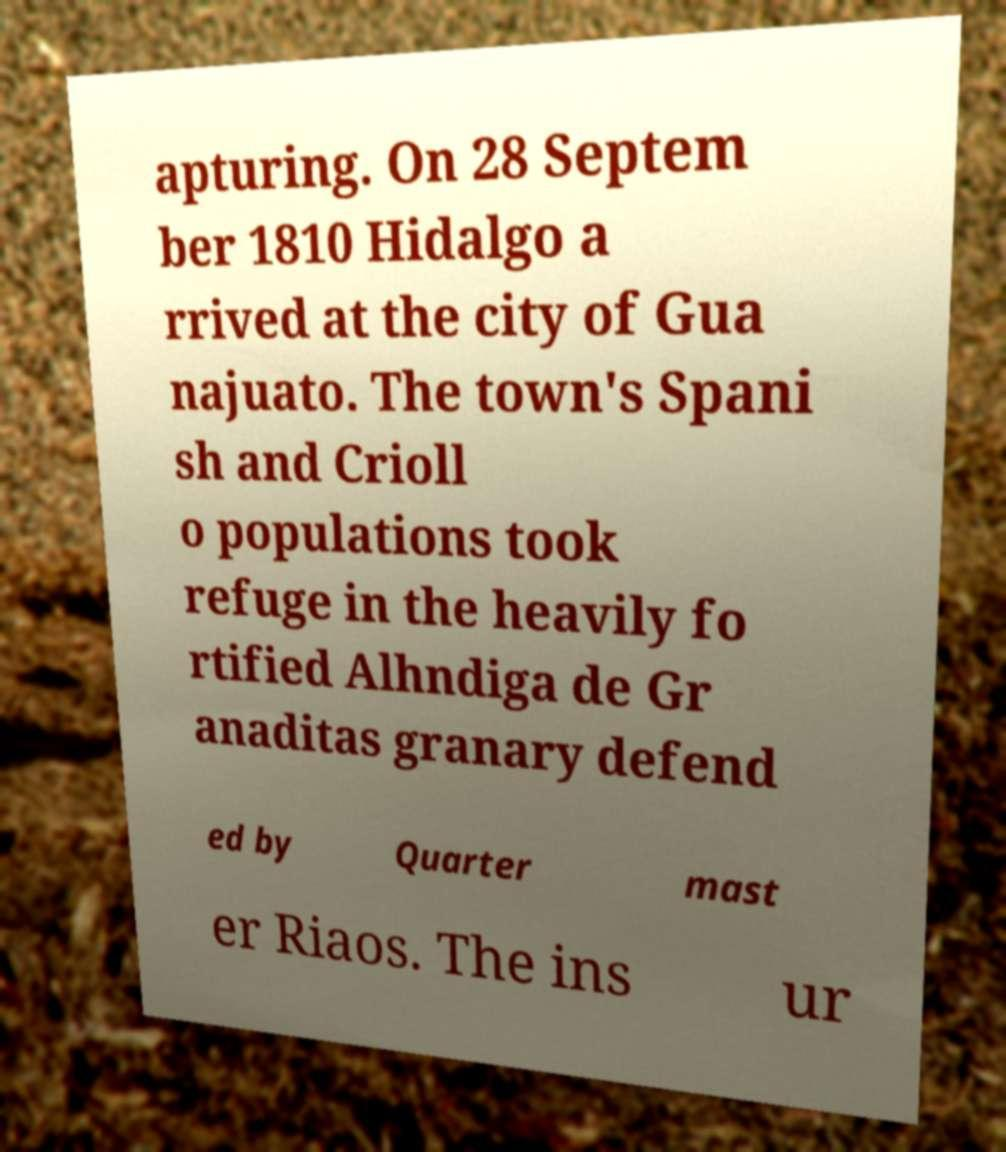Please identify and transcribe the text found in this image. apturing. On 28 Septem ber 1810 Hidalgo a rrived at the city of Gua najuato. The town's Spani sh and Crioll o populations took refuge in the heavily fo rtified Alhndiga de Gr anaditas granary defend ed by Quarter mast er Riaos. The ins ur 